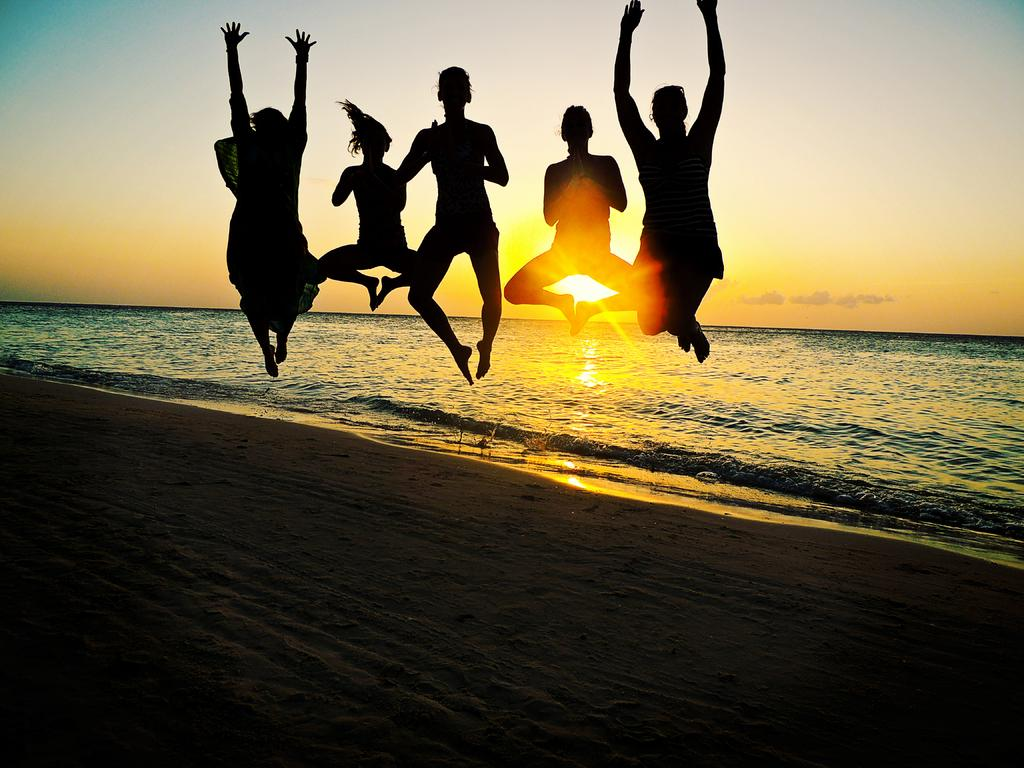What are the people in the image doing? The people in the image are posing for a photo. Where are the people located in relation to the ocean? The people are near the ocean. What can be seen in the background of the image? The ocean and sky are visible in the background of the image. Can the sun be seen in the sky? Yes, the sun is observable in the sky. What is the value of the clam found on the beach in the image? There is no clam present in the image, so it is not possible to determine its value. 